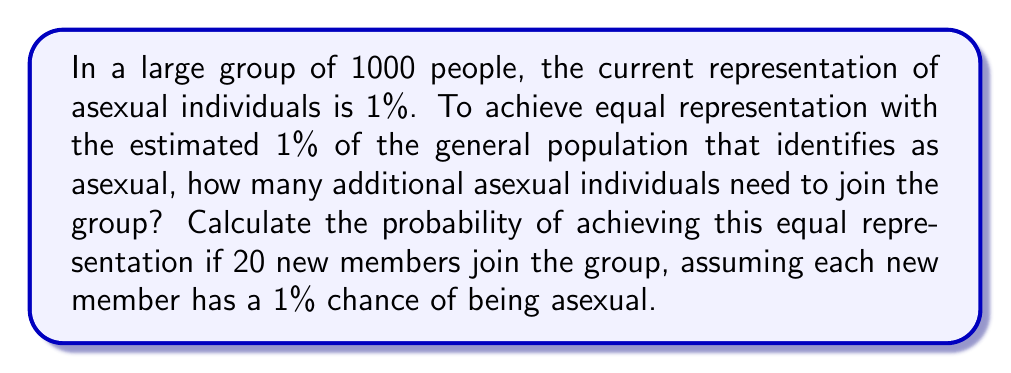Provide a solution to this math problem. Let's approach this step-by-step:

1) Current number of asexual individuals in the group:
   $1000 \times 1\% = 10$ individuals

2) To achieve equal representation (1% of 1020 total people after new members join):
   $1020 \times 1\% = 10.2$, which rounds to 11 individuals

3) Additional asexual individuals needed:
   $11 - 10 = 1$ individual

4) Now, we need to calculate the probability of getting at least 1 asexual individual out of 20 new members.

5) Let's use the binomial probability formula:
   $$P(X \geq 1) = 1 - P(X = 0)$$
   Where $X$ is the number of asexual individuals in the 20 new members.

6) $P(X = 0)$ can be calculated as:
   $$P(X = 0) = \binom{20}{0} (0.01)^0 (0.99)^{20}$$

7) Calculating:
   $$P(X = 0) = 1 \times 1 \times 0.99^{20} \approx 0.8179$$

8) Therefore:
   $$P(X \geq 1) = 1 - 0.8179 \approx 0.1821$$

Thus, the probability of achieving equal representation is approximately 0.1821 or 18.21%.
Answer: 0.1821 